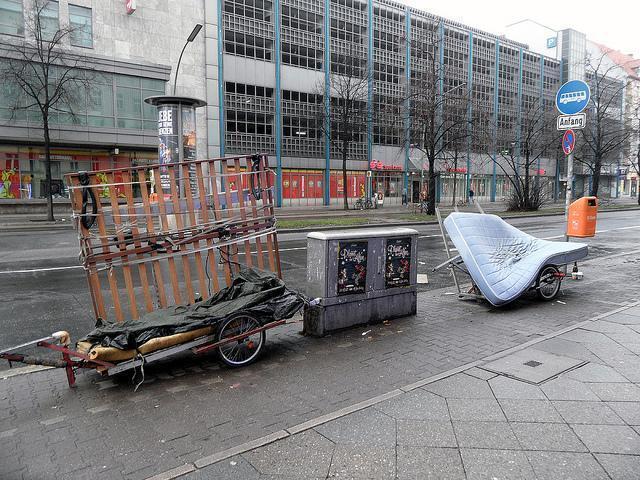What is being hauled on the right?
Select the correct answer and articulate reasoning with the following format: 'Answer: answer
Rationale: rationale.'
Options: Sofa, nightstand, recliner, mattress. Answer: mattress.
Rationale: There is a bed frame on the left. the rectangular object on the right goes on the bed frame. 